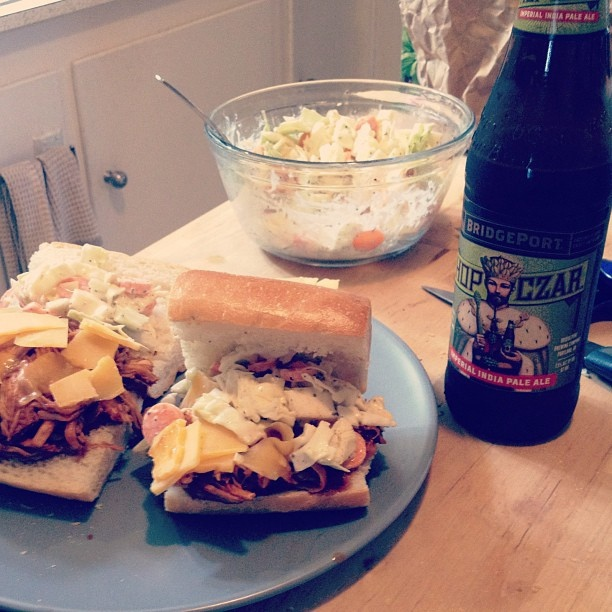Describe the objects in this image and their specific colors. I can see dining table in ivory, navy, salmon, brown, and gray tones, bottle in beige, navy, and gray tones, sandwich in ivory, tan, brown, and navy tones, bowl in ivory, tan, darkgray, and beige tones, and sandwich in ivory, tan, brown, and salmon tones in this image. 